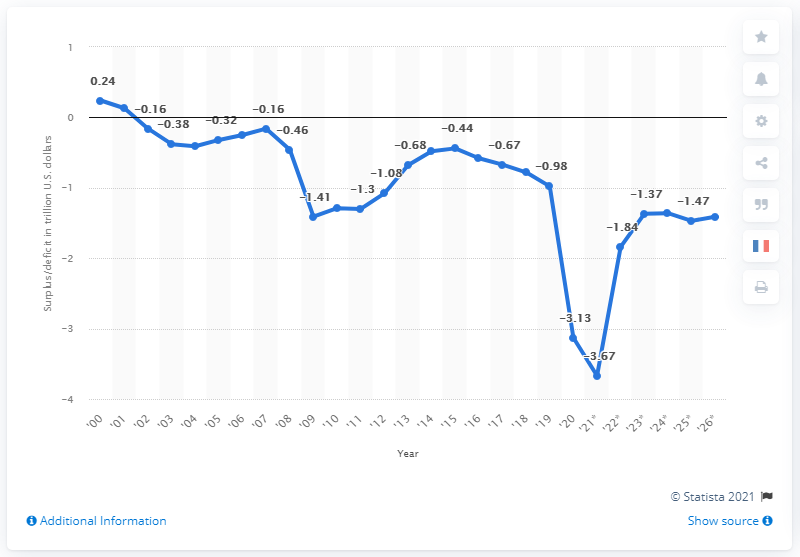Outline some significant characteristics in this image. The budget surplus in 2000 was 0.24. 